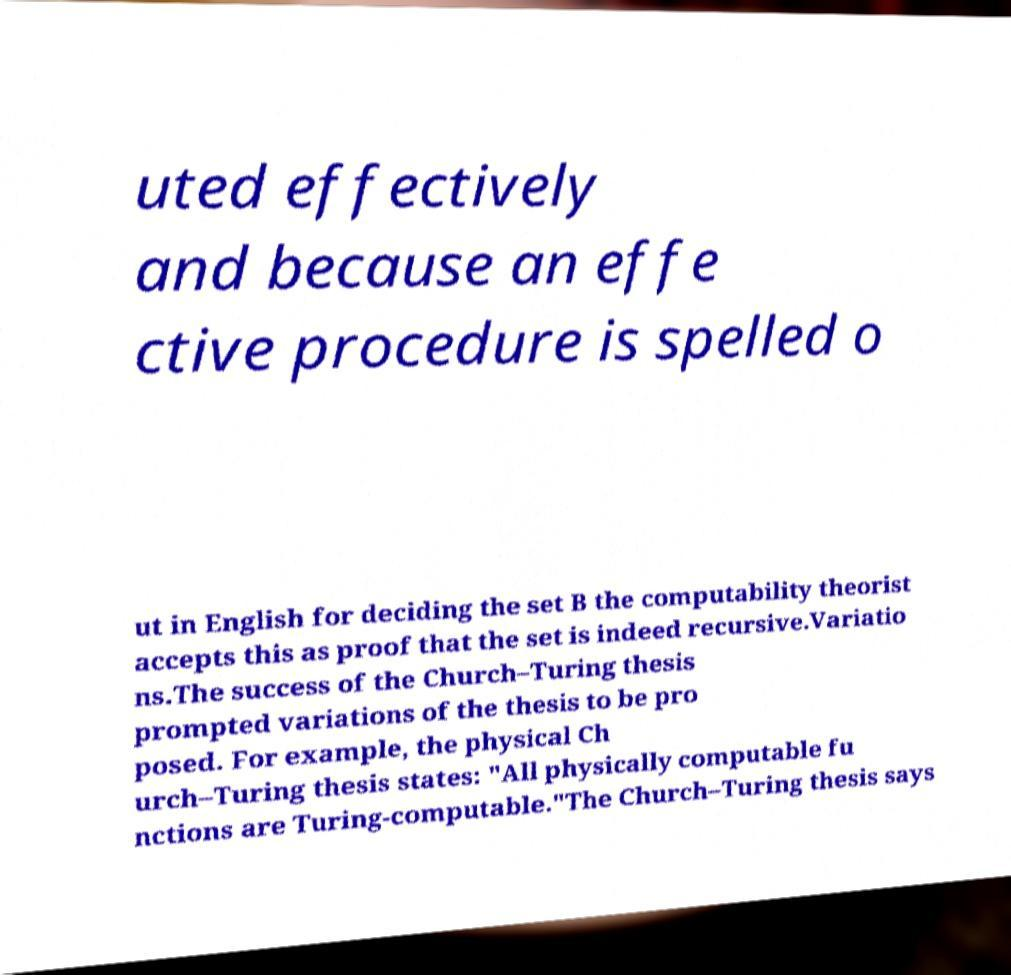Can you read and provide the text displayed in the image?This photo seems to have some interesting text. Can you extract and type it out for me? uted effectively and because an effe ctive procedure is spelled o ut in English for deciding the set B the computability theorist accepts this as proof that the set is indeed recursive.Variatio ns.The success of the Church–Turing thesis prompted variations of the thesis to be pro posed. For example, the physical Ch urch–Turing thesis states: "All physically computable fu nctions are Turing-computable."The Church–Turing thesis says 